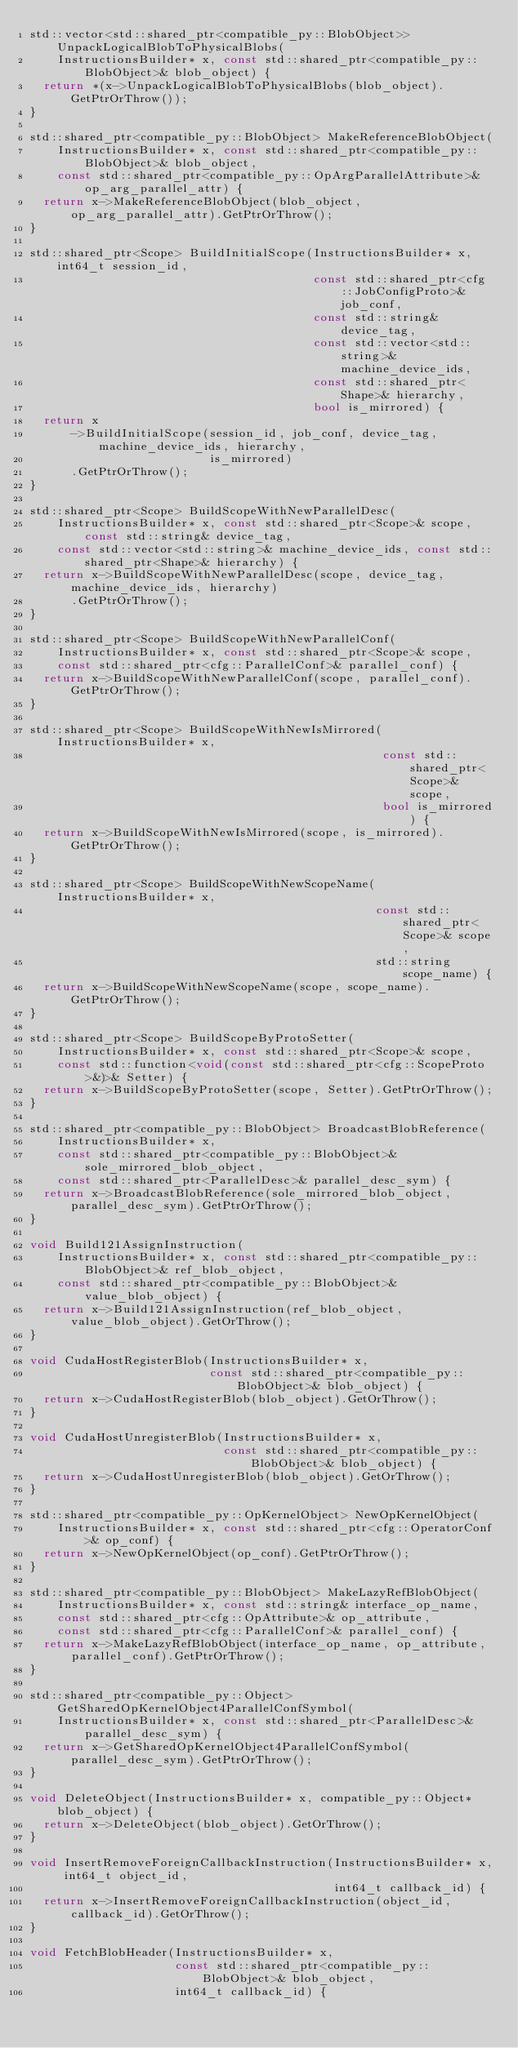<code> <loc_0><loc_0><loc_500><loc_500><_C++_>std::vector<std::shared_ptr<compatible_py::BlobObject>> UnpackLogicalBlobToPhysicalBlobs(
    InstructionsBuilder* x, const std::shared_ptr<compatible_py::BlobObject>& blob_object) {
  return *(x->UnpackLogicalBlobToPhysicalBlobs(blob_object).GetPtrOrThrow());
}

std::shared_ptr<compatible_py::BlobObject> MakeReferenceBlobObject(
    InstructionsBuilder* x, const std::shared_ptr<compatible_py::BlobObject>& blob_object,
    const std::shared_ptr<compatible_py::OpArgParallelAttribute>& op_arg_parallel_attr) {
  return x->MakeReferenceBlobObject(blob_object, op_arg_parallel_attr).GetPtrOrThrow();
}

std::shared_ptr<Scope> BuildInitialScope(InstructionsBuilder* x, int64_t session_id,
                                         const std::shared_ptr<cfg::JobConfigProto>& job_conf,
                                         const std::string& device_tag,
                                         const std::vector<std::string>& machine_device_ids,
                                         const std::shared_ptr<Shape>& hierarchy,
                                         bool is_mirrored) {
  return x
      ->BuildInitialScope(session_id, job_conf, device_tag, machine_device_ids, hierarchy,
                          is_mirrored)
      .GetPtrOrThrow();
}

std::shared_ptr<Scope> BuildScopeWithNewParallelDesc(
    InstructionsBuilder* x, const std::shared_ptr<Scope>& scope, const std::string& device_tag,
    const std::vector<std::string>& machine_device_ids, const std::shared_ptr<Shape>& hierarchy) {
  return x->BuildScopeWithNewParallelDesc(scope, device_tag, machine_device_ids, hierarchy)
      .GetPtrOrThrow();
}

std::shared_ptr<Scope> BuildScopeWithNewParallelConf(
    InstructionsBuilder* x, const std::shared_ptr<Scope>& scope,
    const std::shared_ptr<cfg::ParallelConf>& parallel_conf) {
  return x->BuildScopeWithNewParallelConf(scope, parallel_conf).GetPtrOrThrow();
}

std::shared_ptr<Scope> BuildScopeWithNewIsMirrored(InstructionsBuilder* x,
                                                   const std::shared_ptr<Scope>& scope,
                                                   bool is_mirrored) {
  return x->BuildScopeWithNewIsMirrored(scope, is_mirrored).GetPtrOrThrow();
}

std::shared_ptr<Scope> BuildScopeWithNewScopeName(InstructionsBuilder* x,
                                                  const std::shared_ptr<Scope>& scope,
                                                  std::string scope_name) {
  return x->BuildScopeWithNewScopeName(scope, scope_name).GetPtrOrThrow();
}

std::shared_ptr<Scope> BuildScopeByProtoSetter(
    InstructionsBuilder* x, const std::shared_ptr<Scope>& scope,
    const std::function<void(const std::shared_ptr<cfg::ScopeProto>&)>& Setter) {
  return x->BuildScopeByProtoSetter(scope, Setter).GetPtrOrThrow();
}

std::shared_ptr<compatible_py::BlobObject> BroadcastBlobReference(
    InstructionsBuilder* x,
    const std::shared_ptr<compatible_py::BlobObject>& sole_mirrored_blob_object,
    const std::shared_ptr<ParallelDesc>& parallel_desc_sym) {
  return x->BroadcastBlobReference(sole_mirrored_blob_object, parallel_desc_sym).GetPtrOrThrow();
}

void Build121AssignInstruction(
    InstructionsBuilder* x, const std::shared_ptr<compatible_py::BlobObject>& ref_blob_object,
    const std::shared_ptr<compatible_py::BlobObject>& value_blob_object) {
  return x->Build121AssignInstruction(ref_blob_object, value_blob_object).GetOrThrow();
}

void CudaHostRegisterBlob(InstructionsBuilder* x,
                          const std::shared_ptr<compatible_py::BlobObject>& blob_object) {
  return x->CudaHostRegisterBlob(blob_object).GetOrThrow();
}

void CudaHostUnregisterBlob(InstructionsBuilder* x,
                            const std::shared_ptr<compatible_py::BlobObject>& blob_object) {
  return x->CudaHostUnregisterBlob(blob_object).GetOrThrow();
}

std::shared_ptr<compatible_py::OpKernelObject> NewOpKernelObject(
    InstructionsBuilder* x, const std::shared_ptr<cfg::OperatorConf>& op_conf) {
  return x->NewOpKernelObject(op_conf).GetPtrOrThrow();
}

std::shared_ptr<compatible_py::BlobObject> MakeLazyRefBlobObject(
    InstructionsBuilder* x, const std::string& interface_op_name,
    const std::shared_ptr<cfg::OpAttribute>& op_attribute,
    const std::shared_ptr<cfg::ParallelConf>& parallel_conf) {
  return x->MakeLazyRefBlobObject(interface_op_name, op_attribute, parallel_conf).GetPtrOrThrow();
}

std::shared_ptr<compatible_py::Object> GetSharedOpKernelObject4ParallelConfSymbol(
    InstructionsBuilder* x, const std::shared_ptr<ParallelDesc>& parallel_desc_sym) {
  return x->GetSharedOpKernelObject4ParallelConfSymbol(parallel_desc_sym).GetPtrOrThrow();
}

void DeleteObject(InstructionsBuilder* x, compatible_py::Object* blob_object) {
  return x->DeleteObject(blob_object).GetOrThrow();
}

void InsertRemoveForeignCallbackInstruction(InstructionsBuilder* x, int64_t object_id,
                                            int64_t callback_id) {
  return x->InsertRemoveForeignCallbackInstruction(object_id, callback_id).GetOrThrow();
}

void FetchBlobHeader(InstructionsBuilder* x,
                     const std::shared_ptr<compatible_py::BlobObject>& blob_object,
                     int64_t callback_id) {</code> 